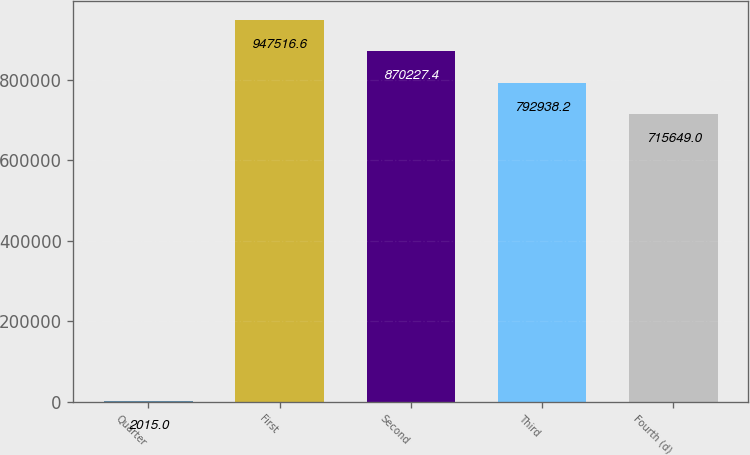Convert chart to OTSL. <chart><loc_0><loc_0><loc_500><loc_500><bar_chart><fcel>Quarter<fcel>First<fcel>Second<fcel>Third<fcel>Fourth (d)<nl><fcel>2015<fcel>947517<fcel>870227<fcel>792938<fcel>715649<nl></chart> 